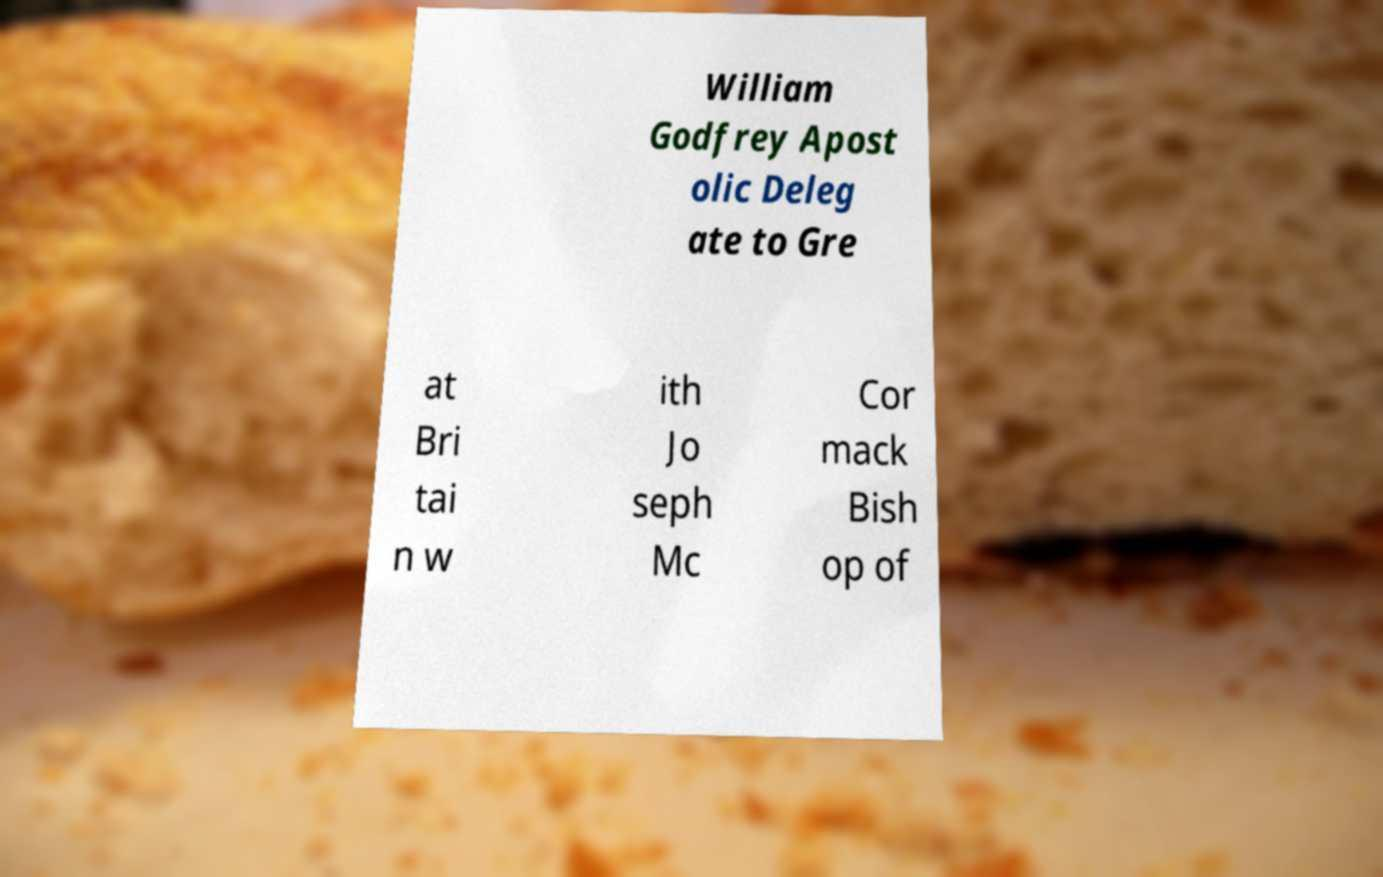Can you read and provide the text displayed in the image?This photo seems to have some interesting text. Can you extract and type it out for me? William Godfrey Apost olic Deleg ate to Gre at Bri tai n w ith Jo seph Mc Cor mack Bish op of 